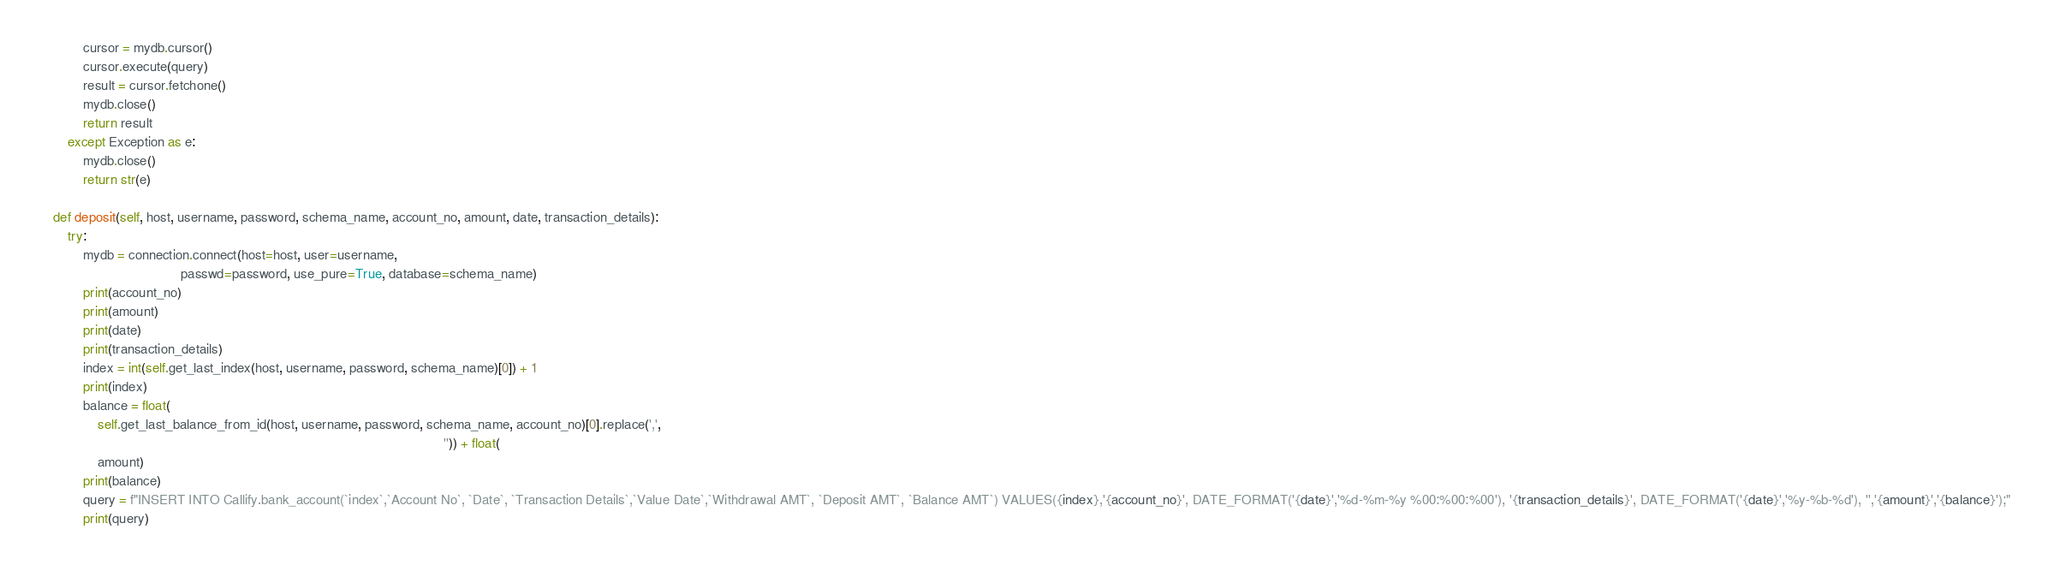<code> <loc_0><loc_0><loc_500><loc_500><_Python_>            cursor = mydb.cursor()
            cursor.execute(query)
            result = cursor.fetchone()
            mydb.close()
            return result
        except Exception as e:
            mydb.close()
            return str(e)

    def deposit(self, host, username, password, schema_name, account_no, amount, date, transaction_details):
        try:
            mydb = connection.connect(host=host, user=username,
                                      passwd=password, use_pure=True, database=schema_name)
            print(account_no)
            print(amount)
            print(date)
            print(transaction_details)
            index = int(self.get_last_index(host, username, password, schema_name)[0]) + 1
            print(index)
            balance = float(
                self.get_last_balance_from_id(host, username, password, schema_name, account_no)[0].replace(',',
                                                                                                            '')) + float(
                amount)
            print(balance)
            query = f"INSERT INTO Callify.bank_account(`index`,`Account No`, `Date`, `Transaction Details`,`Value Date`,`Withdrawal AMT`, `Deposit AMT`, `Balance AMT`) VALUES({index},'{account_no}', DATE_FORMAT('{date}','%d-%m-%y %00:%00:%00'), '{transaction_details}', DATE_FORMAT('{date}','%y-%b-%d'), '','{amount}','{balance}');"
            print(query)</code> 